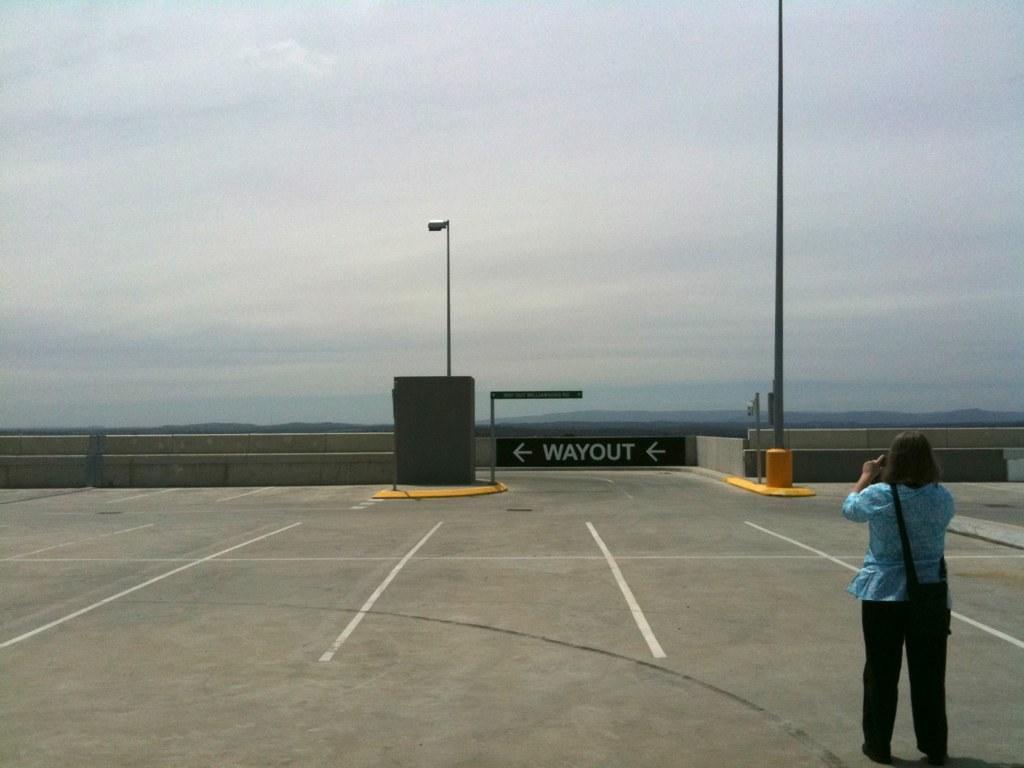Can you describe this image briefly? Bottom right side of the image a woman is standing and holding something in her hand. Behind her there are some poles and fencing. Behind the fencing there are some clouds and sky. 